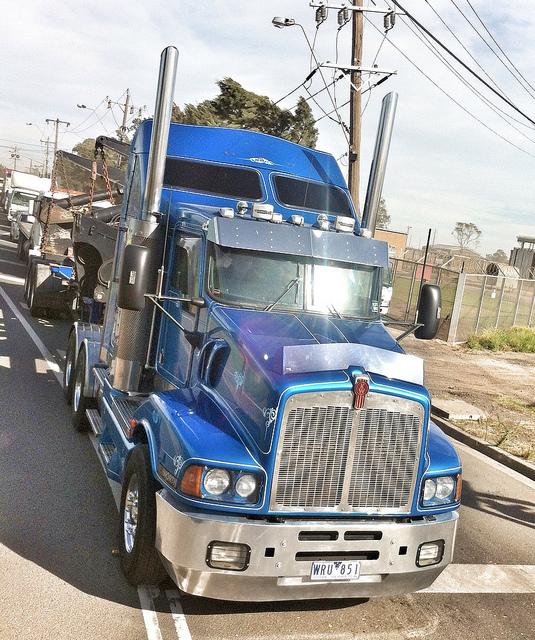What color is the truck?
Be succinct. Blue. Does the truck have outrigger mirrors?
Give a very brief answer. Yes. Is there a place to sleep in this truck?
Give a very brief answer. Yes. 